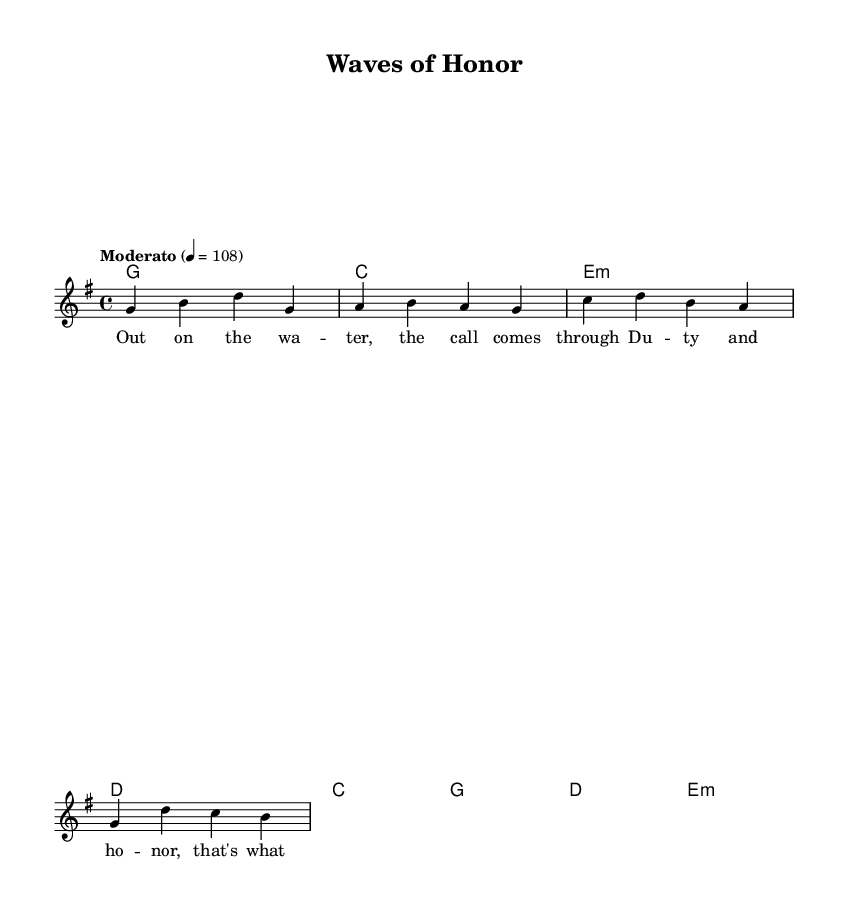What is the key signature of this music? The key signature is G major, which has one sharp (F#). This is indicated at the beginning of the sheet music right after the time signature.
Answer: G major What is the time signature of this music? The time signature is 4/4, which means there are four beats per measure and each quarter note gets one beat. This can be found at the beginning of the score.
Answer: 4/4 What is the tempo marking for this piece? The tempo marking is "Moderato" with a tempo of 108 beats per minute. This is specified in the tempo indication section at the top of the score.
Answer: Moderato 4 = 108 How many measures are in the verse section? The verse section consists of 4 measures, as indicated by the number of segments between the bar lines in the melody part. By counting the measures shown in the melody, we confirm that there are indeed 4 measures.
Answer: 4 What is the harmonic structure of the chorus? The harmonic structure of the chorus is C, G, D, E minor. This can be determined by looking at the chord mode section, where the chords listed under the chorus lyrics indicate the harmonic progression.
Answer: C, G, D, E minor What themes are represented in the lyrics? The themes represented in the lyrics are duty, honor, and mission. Analyzing the words in the verse and chorus, it's clear that they center on search and rescue work and the commitment involved in that service.
Answer: Duty, honor, mission What genre does this piece belong to? The piece belongs to the Country Rock genre, as indicated by the style of the music as well as the lyrical content which often reflects the stories and values found in country rock music.
Answer: Country Rock 